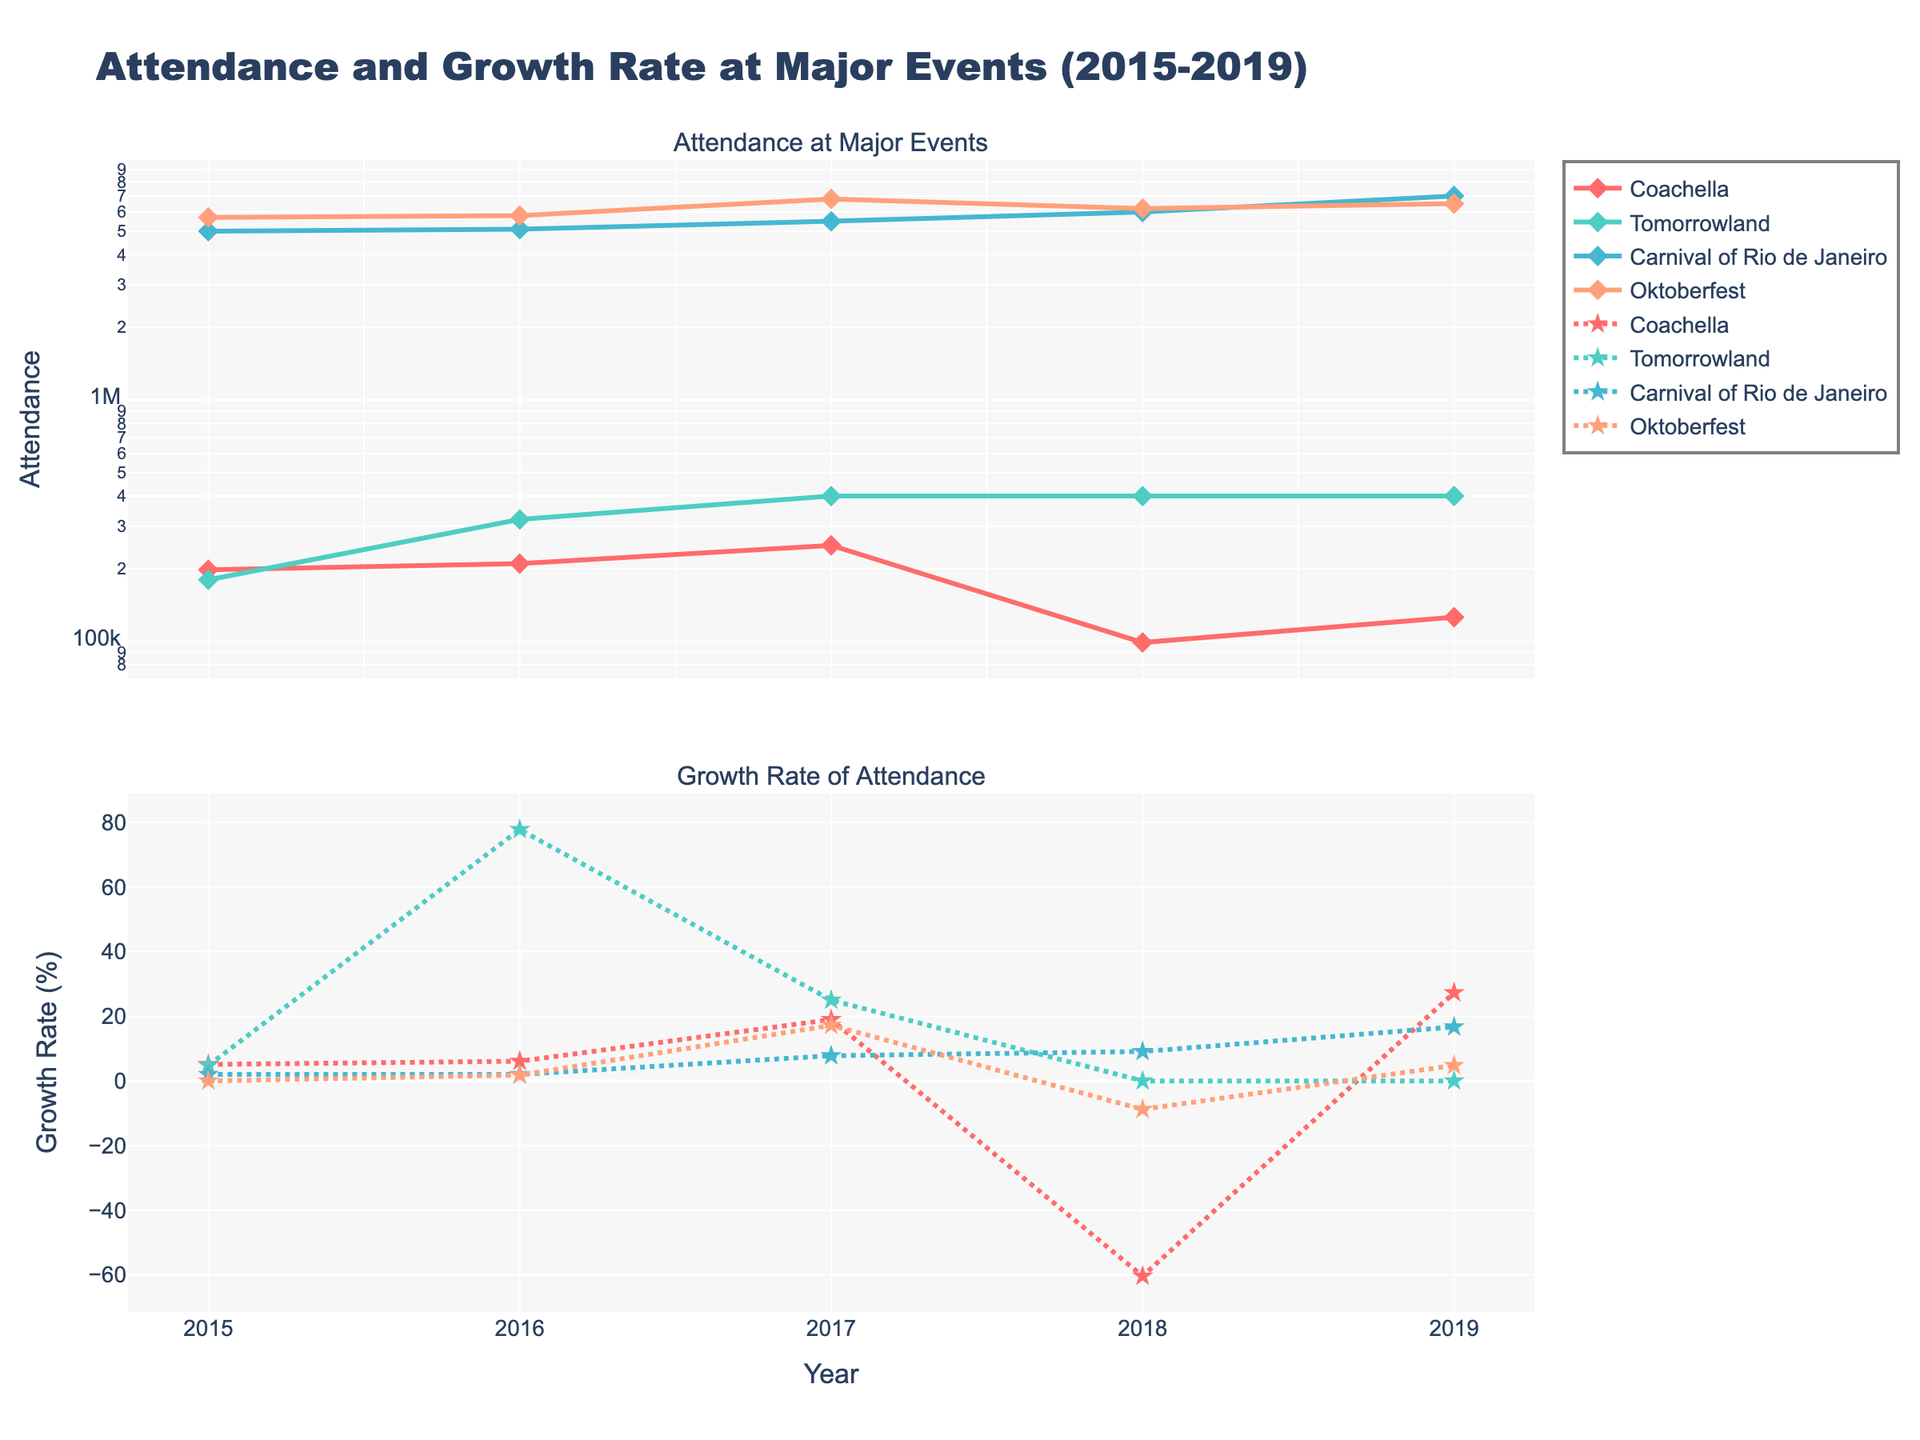what is the title of the plot? The plot has a visible main title, which is usually located at the top center of the plot area. Reading the title from the plot gives us this information.
Answer: Attendance and Growth Rate at Major Events (2015-2019) Which event had the highest attendance in 2019? By observing the attendance subplot for the year 2019, we compare the height of the attendance lines for each event. The Carnival of Rio de Janeiro line is the highest in 2019.
Answer: Carnival of Rio de Janeiro Which event had the lowest growth rate in 2018? In the growth rate subplot for the year 2018, we find the lowest point by comparing the dots representing each event. Coachella had a -60.4% growth rate, the lowest among the events.
Answer: Coachella Which event's attendance shows an increasing trend over the years? We look at the attendance subplot and observe the lines. An increasing trend means the line goes upwards from 2015 to 2019. The Carnival of Rio de Janeiro shows a clear upward trend from 2015 to 2019.
Answer: Carnival of Rio de Janeiro What was the attendance of Oktoberfest in 2018, and what was its growth rate in that year? We locate Oktoberfest in the attendance subplot and find the 2018 data point, reading the y-axis value. Then, we check the corresponding point in the growth rate subplot. The attendance was around 6,200,000 and the growth rate was -8.8%.
Answer: 6,200,000 and -8.8% Between Tomorrowland and Coachella, which event had a higher growth rate in 2016? By comparing the heights of the dots in the growth rate subplot for 2016, we see that Tomorrowland's growth rate is higher compared to Coachella's.
Answer: Tomorrowland What is the range of growth rates observed for the Carnival of Rio de Janeiro? We focus on the growth rate subplot and check the highest and lowest data points for the Carnival of Rio de Janeiro. The growth ranges from 2% in 2015 and 2016 to 16.7% in 2019.
Answer: 2% to 16.7% Which event had the steepest decline in attendance in any year? By analyzing the attendance subplot, we find the largest downward drop. Coachella shows a significant drop from 2017 to 2018.
Answer: Coachella What is the color used to represent Tomorrowland? We identify the line representing Tomorrowland in both subplots and note its color. The color used is a shade of teal associated with Tomorrowland.
Answer: Teal 